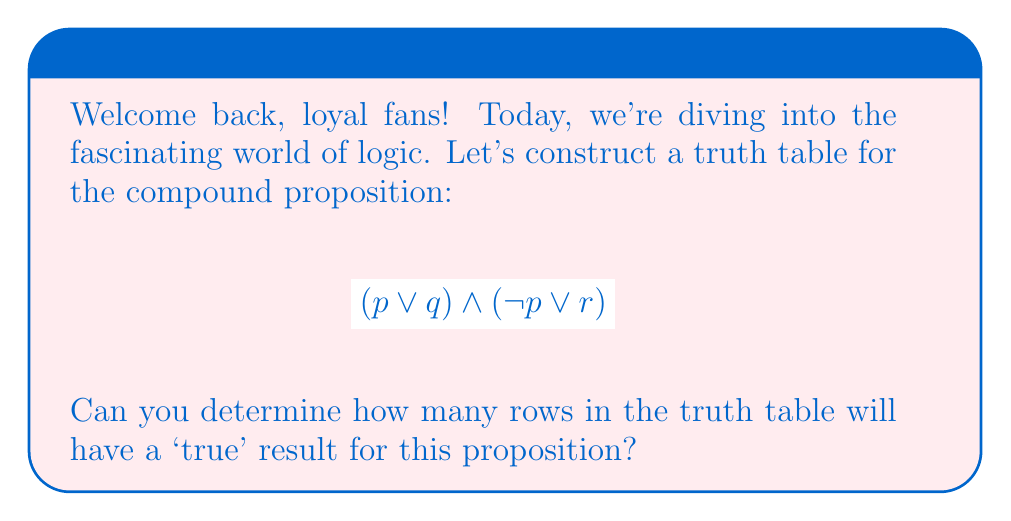Teach me how to tackle this problem. Let's break this down step-by-step:

1) First, we need to identify the individual propositions: $p$, $q$, and $r$.

2) With 3 propositions, our truth table will have $2^3 = 8$ rows.

3) Let's construct the truth table:

   | $p$ | $q$ | $r$ | $p \lor q$ | $\neg p$ | $\neg p \lor r$ | $(p \lor q) \land (\neg p \lor r)$ |
   |-----|-----|-----|------------|----------|-----------------|-------------------------------------|
   | T   | T   | T   | T          | F        | T               | T                                   |
   | T   | T   | F   | T          | F        | F               | F                                   |
   | T   | F   | T   | T          | F        | T               | T                                   |
   | T   | F   | F   | T          | F        | F               | F                                   |
   | F   | T   | T   | T          | T        | T               | T                                   |
   | F   | T   | F   | T          | T        | T               | T                                   |
   | F   | F   | T   | F          | T        | T               | F                                   |
   | F   | F   | F   | F          | T        | T               | F                                   |

4) Now, we count the number of 'T' results in the final column.

5) We can see that there are 4 rows where the final result is 'T'.

Therefore, 4 rows in the truth table have a 'true' result for this compound proposition.
Answer: 4 